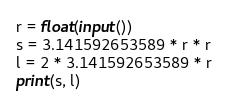<code> <loc_0><loc_0><loc_500><loc_500><_Python_>r = float(input())
s = 3.141592653589 * r * r
l = 2 * 3.141592653589 * r
print(s, l)
</code> 